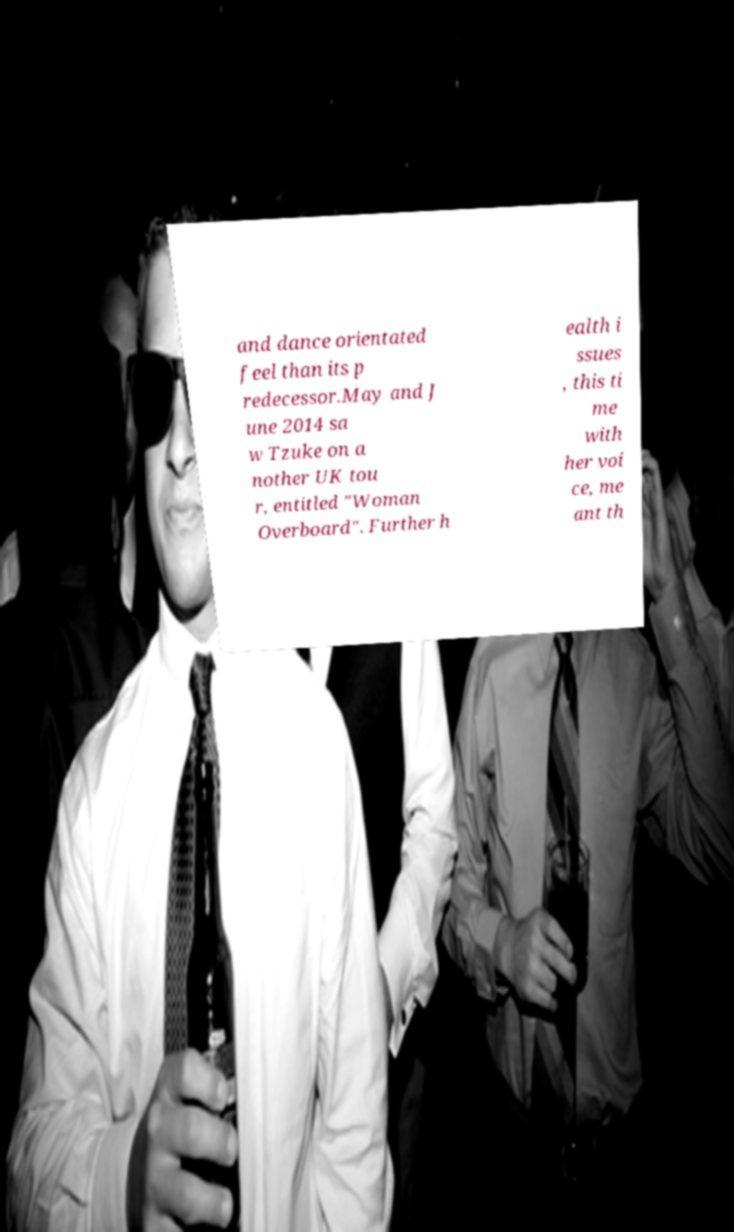Could you extract and type out the text from this image? and dance orientated feel than its p redecessor.May and J une 2014 sa w Tzuke on a nother UK tou r, entitled "Woman Overboard". Further h ealth i ssues , this ti me with her voi ce, me ant th 